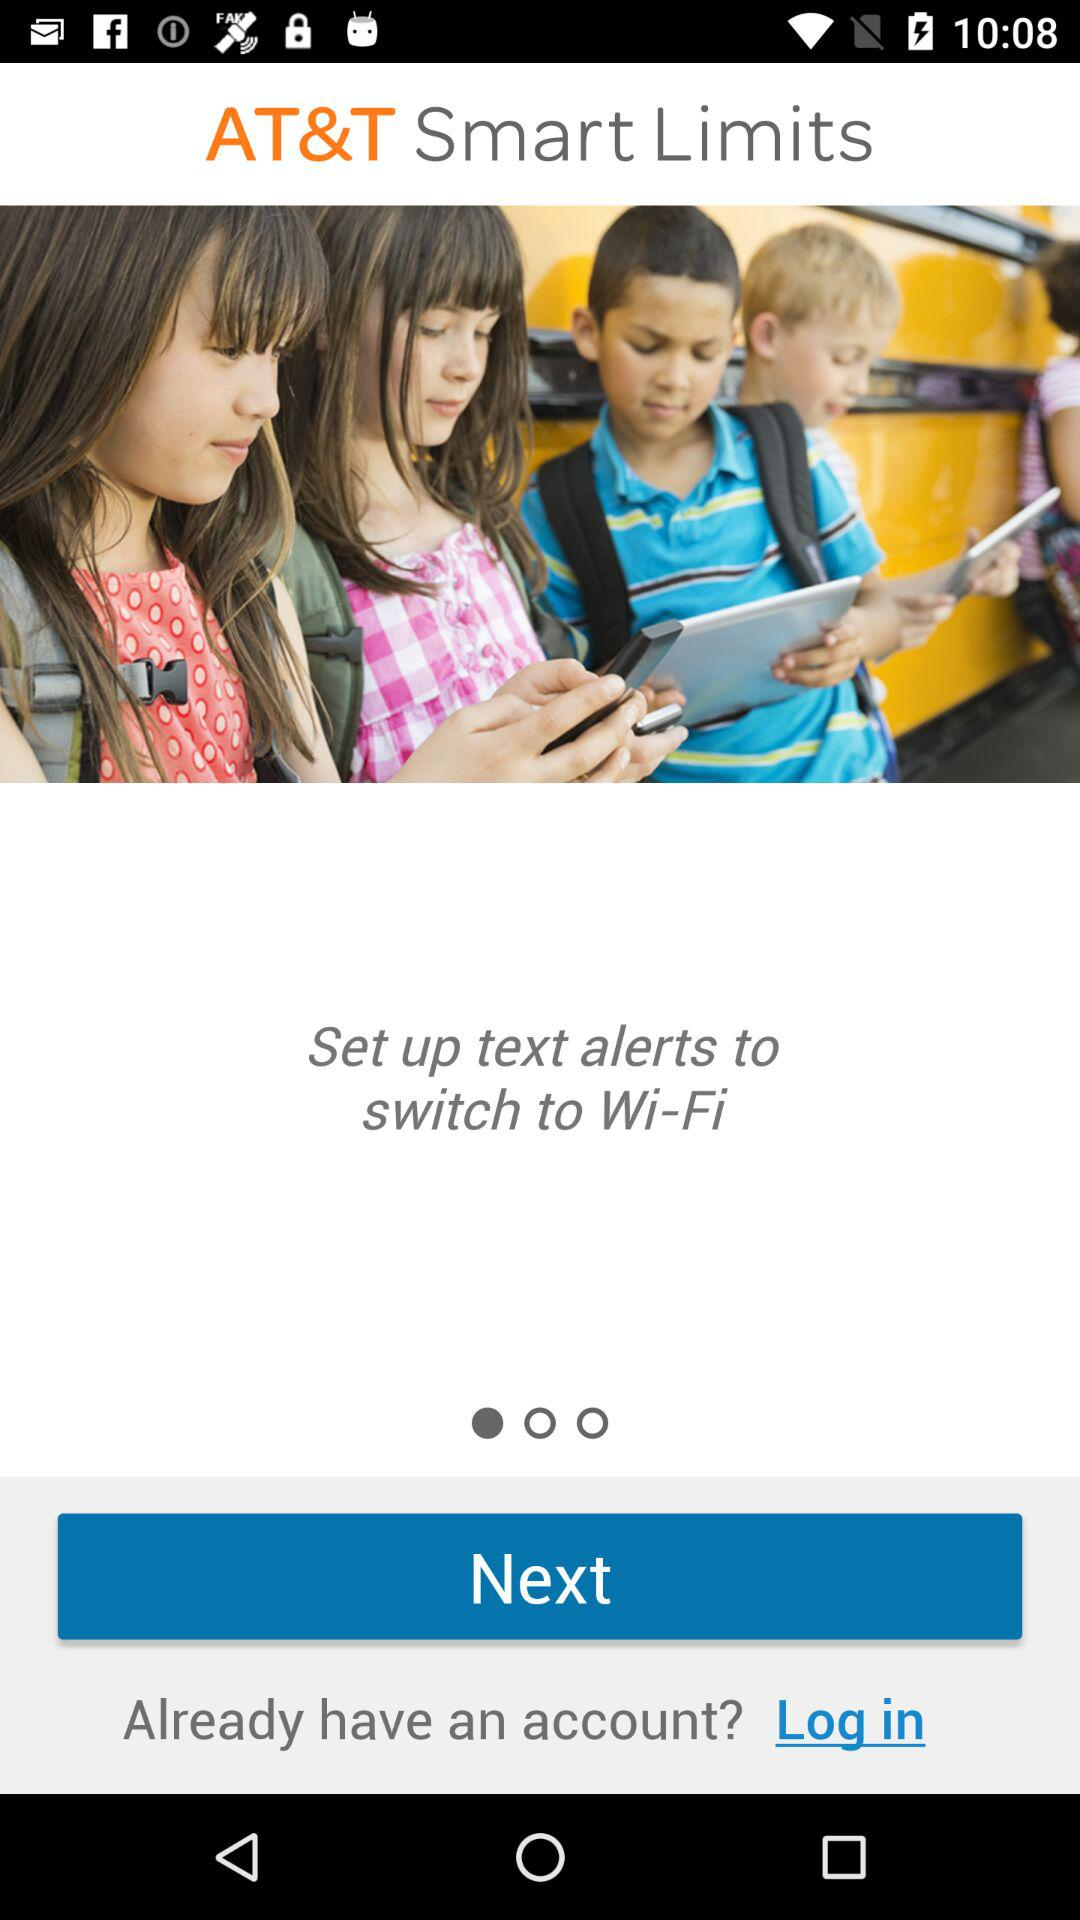What is the application name? The application name is "AT&T Smart Limits". 